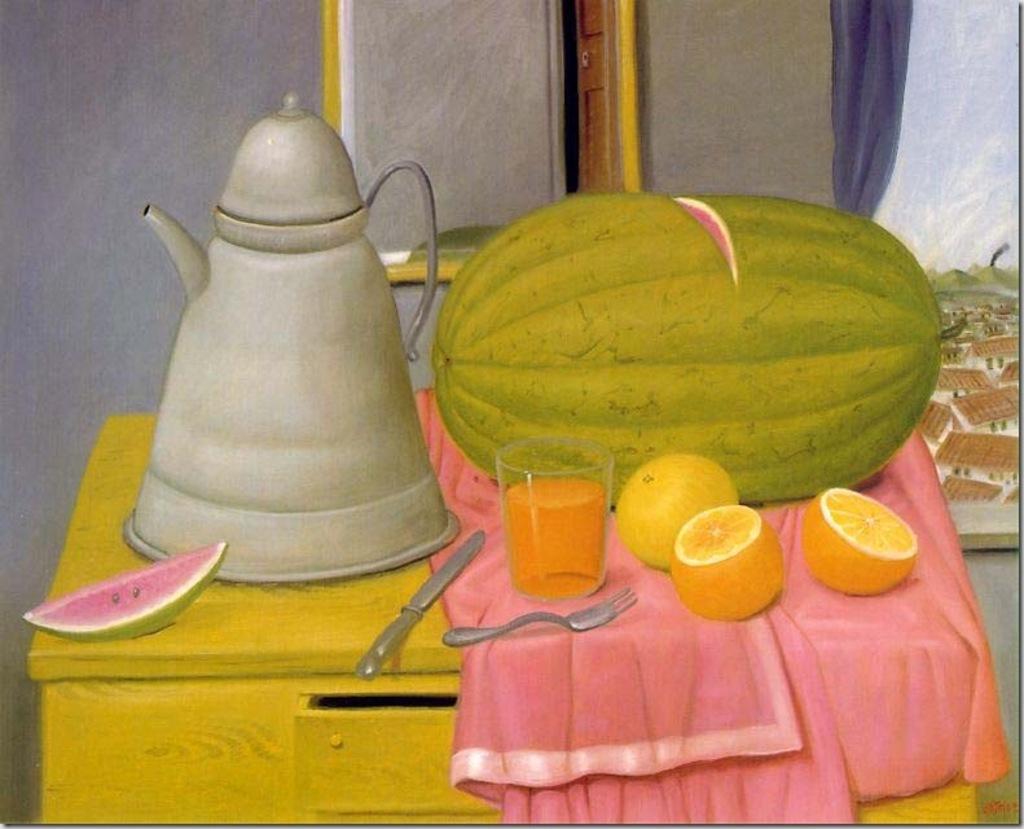How would you summarize this image in a sentence or two? This image consists of a poster with an art. In the background there is a wall with a picture frame on it. In the middle of the image there is a table with a jug, a table cloth, a knife, fork, watermelon, a watermelon slice, a glass with juice and oranges on it. 